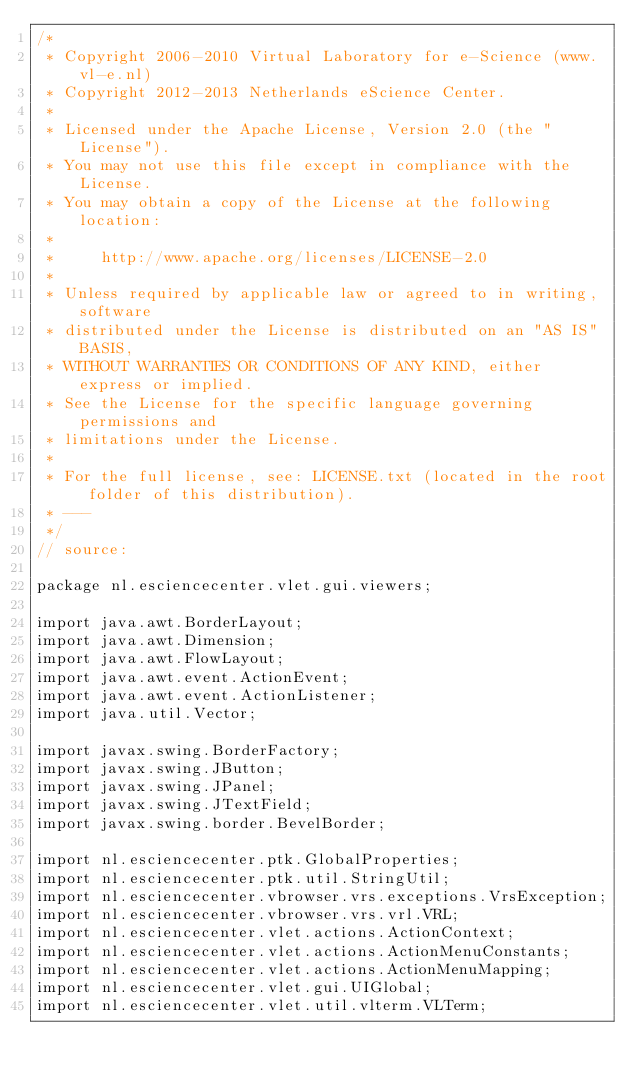<code> <loc_0><loc_0><loc_500><loc_500><_Java_>/*
 * Copyright 2006-2010 Virtual Laboratory for e-Science (www.vl-e.nl)
 * Copyright 2012-2013 Netherlands eScience Center.
 *
 * Licensed under the Apache License, Version 2.0 (the "License").
 * You may not use this file except in compliance with the License. 
 * You may obtain a copy of the License at the following location:
 *
 *     http://www.apache.org/licenses/LICENSE-2.0
 *
 * Unless required by applicable law or agreed to in writing, software
 * distributed under the License is distributed on an "AS IS" BASIS,
 * WITHOUT WARRANTIES OR CONDITIONS OF ANY KIND, either express or implied.
 * See the License for the specific language governing permissions and
 * limitations under the License.
 * 
 * For the full license, see: LICENSE.txt (located in the root folder of this distribution).
 * ---
 */
// source:

package nl.esciencecenter.vlet.gui.viewers;

import java.awt.BorderLayout;
import java.awt.Dimension;
import java.awt.FlowLayout;
import java.awt.event.ActionEvent;
import java.awt.event.ActionListener;
import java.util.Vector;

import javax.swing.BorderFactory;
import javax.swing.JButton;
import javax.swing.JPanel;
import javax.swing.JTextField;
import javax.swing.border.BevelBorder;

import nl.esciencecenter.ptk.GlobalProperties;
import nl.esciencecenter.ptk.util.StringUtil;
import nl.esciencecenter.vbrowser.vrs.exceptions.VrsException;
import nl.esciencecenter.vbrowser.vrs.vrl.VRL;
import nl.esciencecenter.vlet.actions.ActionContext;
import nl.esciencecenter.vlet.actions.ActionMenuConstants;
import nl.esciencecenter.vlet.actions.ActionMenuMapping;
import nl.esciencecenter.vlet.gui.UIGlobal;
import nl.esciencecenter.vlet.util.vlterm.VLTerm;</code> 